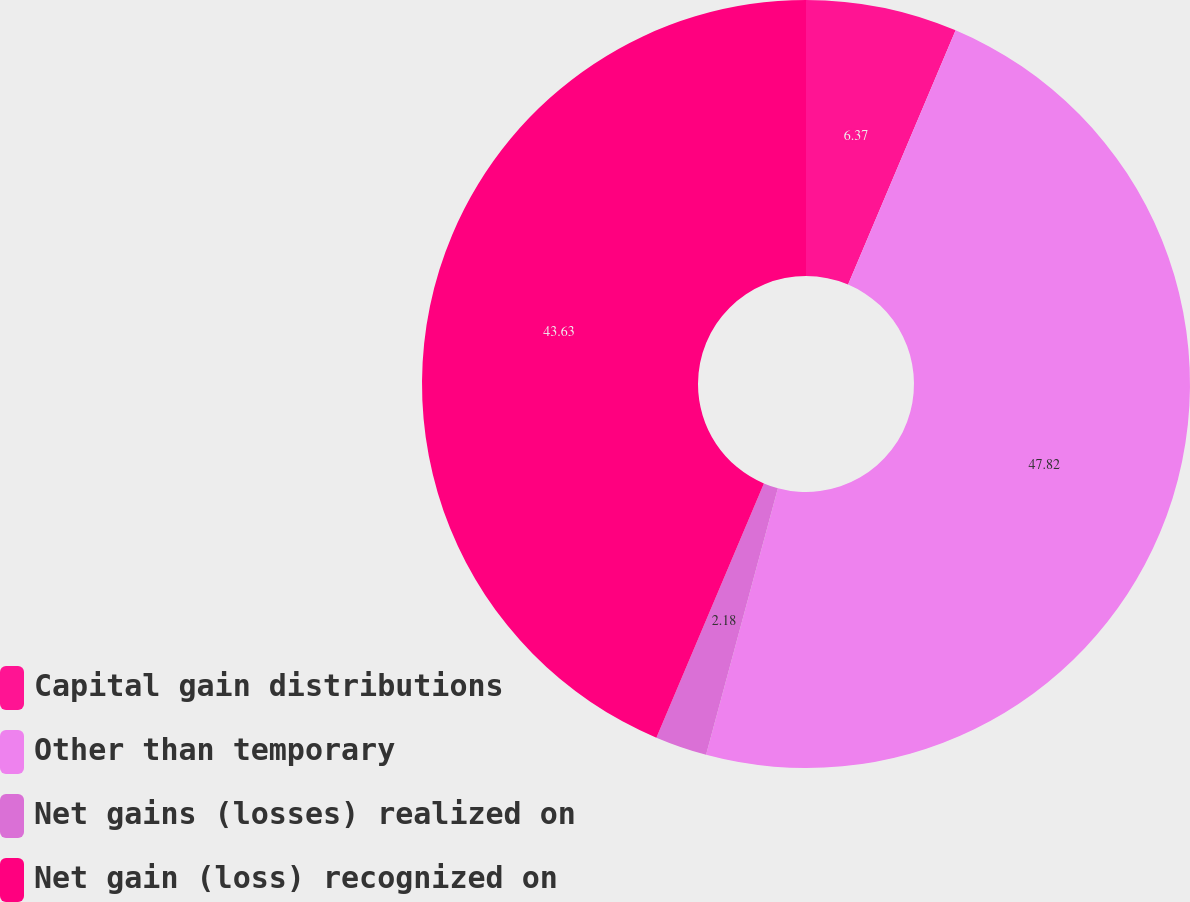Convert chart. <chart><loc_0><loc_0><loc_500><loc_500><pie_chart><fcel>Capital gain distributions<fcel>Other than temporary<fcel>Net gains (losses) realized on<fcel>Net gain (loss) recognized on<nl><fcel>6.37%<fcel>47.82%<fcel>2.18%<fcel>43.63%<nl></chart> 